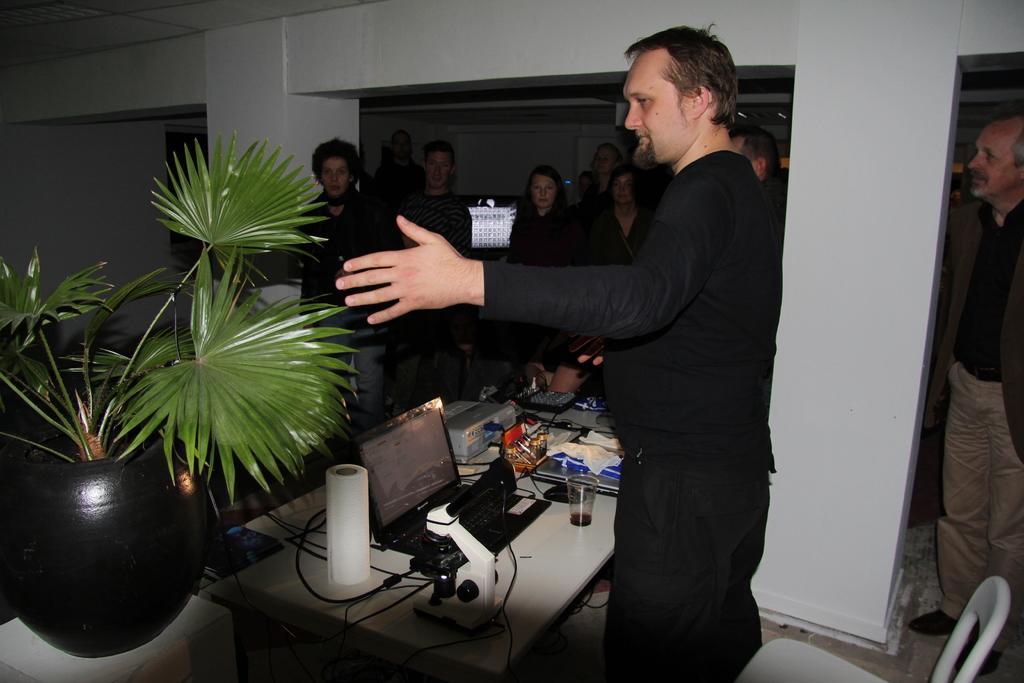Could you give a brief overview of what you see in this image? In this picture there are people and we can see laptop, glass, cables and objects on the table. We can see plant with pot on the white platform and pillars. In the background of the image we can see wall. 